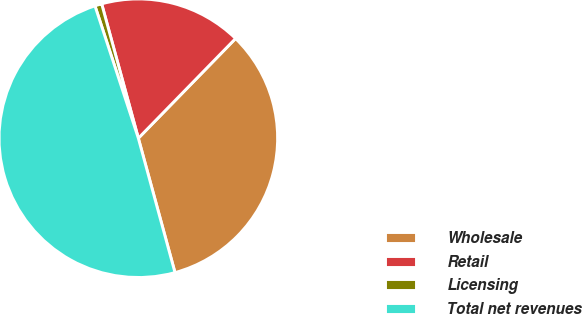Convert chart. <chart><loc_0><loc_0><loc_500><loc_500><pie_chart><fcel>Wholesale<fcel>Retail<fcel>Licensing<fcel>Total net revenues<nl><fcel>33.46%<fcel>16.54%<fcel>0.8%<fcel>49.2%<nl></chart> 